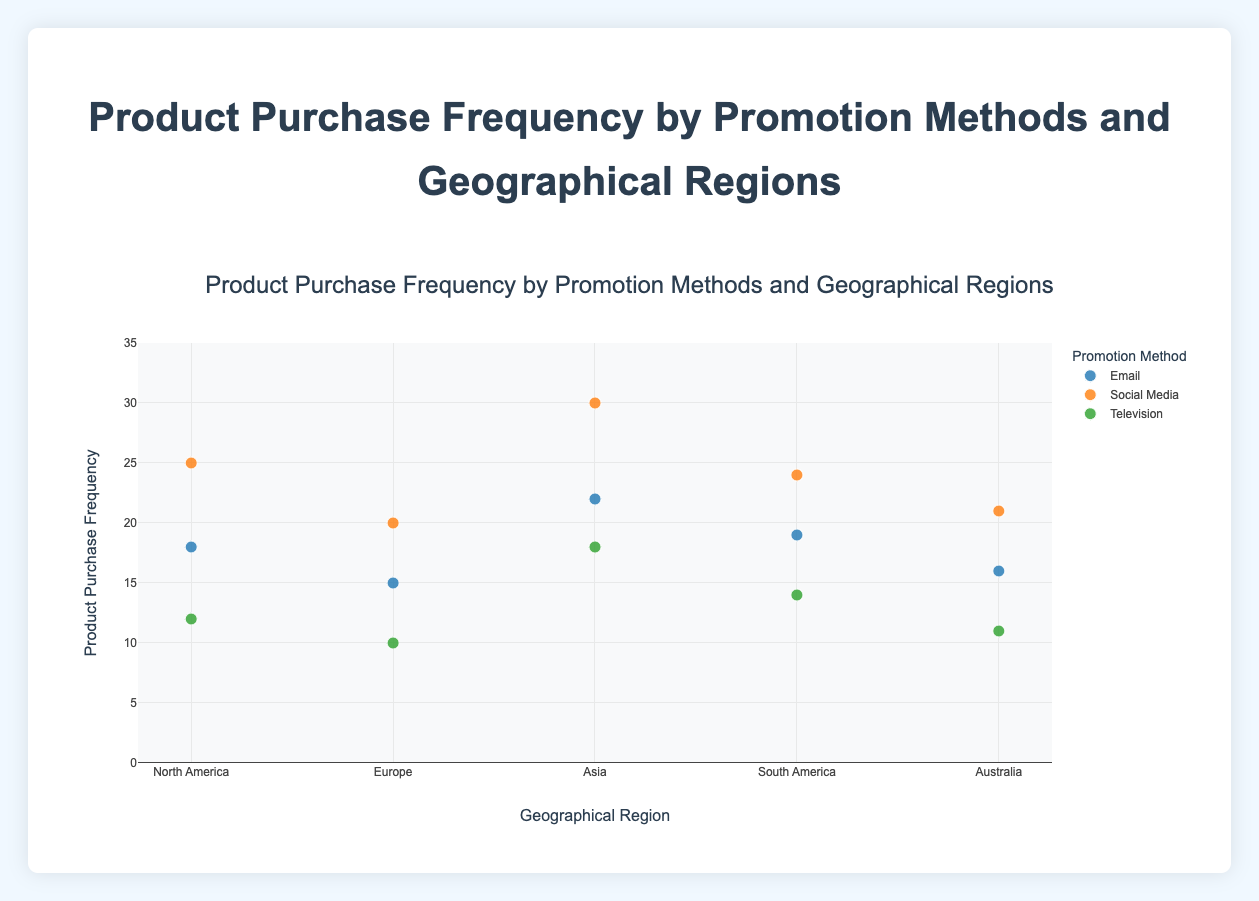What's the title of the figure? The title of the figure is usually displayed prominently at the top. The title helps the viewer understand what the plot is about.
Answer: Product Purchase Frequency by Promotion Methods and Geographical Regions What are the three types of promotion methods shown in the plot? By looking at the legend in the figure, we can see different colors representing different promotion methods.
Answer: Email, Social Media, Television Which promotion method had the highest product purchase frequency in North America? In North America, the data points for product purchase frequency can be seen by looking at the Y-axis values corresponding to different promotion methods in the legend. The highest point among them indicates the method with the highest product purchase frequency.
Answer: Social Media What is the approximate range of the Y-axis? The Y-axis extends from the lowest to the highest value shown in the plot. By observing the ticks on the Y-axis, we can determine the range.
Answer: 0 to 35 Which geographical region shows the highest product purchase frequency for Social Media? We need to scan the data points for Social Media promotion method across all regions and identify the region with the highest Y-value for this method.
Answer: Asia What is the sum of the product purchase frequencies for Social Media in North America and Europe? We need to find the product purchase frequencies for Social Media in North America and Europe by looking at the Y-axis, and then add these two values together.
Answer: 25 + 20 = 45 How does the product purchase frequency of Television in South America compare to that in Australia? We need to observe the Y-values for Television in both South America and Australia and compare them to see which one is higher or if they are equal.
Answer: South America (14) is greater than Australia (11) What is the average product purchase frequency for Email across all geographical regions? We need to sum the product purchase frequencies for Email across all regions, then divide by the number of regions.
Answer: (18 + 15 + 22 + 19 + 16) / 5 = 18 What is the difference in product purchase frequency between Social Media and Television in Asia? Find the product purchase frequencies for Social Media and Television in Asia, then subtract Television from Social Media.
Answer: 30 - 18 = 12 How many regions are represented in the plot? By examining the X-axis, we can count the number of different geographical regions displayed in the plot.
Answer: 5 regions 